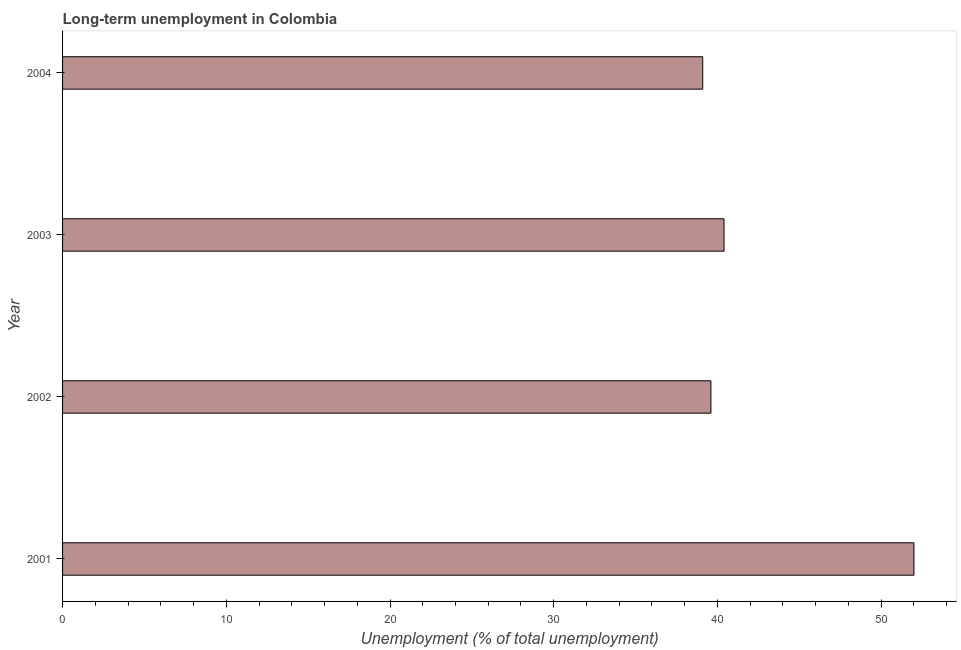What is the title of the graph?
Offer a terse response. Long-term unemployment in Colombia. What is the label or title of the X-axis?
Offer a terse response. Unemployment (% of total unemployment). What is the long-term unemployment in 2001?
Offer a very short reply. 52. Across all years, what is the maximum long-term unemployment?
Your answer should be compact. 52. Across all years, what is the minimum long-term unemployment?
Give a very brief answer. 39.1. In which year was the long-term unemployment maximum?
Provide a short and direct response. 2001. What is the sum of the long-term unemployment?
Your answer should be very brief. 171.1. What is the average long-term unemployment per year?
Offer a terse response. 42.77. Do a majority of the years between 2003 and 2004 (inclusive) have long-term unemployment greater than 6 %?
Your response must be concise. Yes. What is the ratio of the long-term unemployment in 2001 to that in 2004?
Give a very brief answer. 1.33. What is the difference between the highest and the second highest long-term unemployment?
Your answer should be very brief. 11.6. Is the sum of the long-term unemployment in 2001 and 2003 greater than the maximum long-term unemployment across all years?
Ensure brevity in your answer.  Yes. What is the difference between the highest and the lowest long-term unemployment?
Keep it short and to the point. 12.9. In how many years, is the long-term unemployment greater than the average long-term unemployment taken over all years?
Your answer should be compact. 1. Are all the bars in the graph horizontal?
Provide a succinct answer. Yes. How many years are there in the graph?
Ensure brevity in your answer.  4. What is the Unemployment (% of total unemployment) in 2002?
Ensure brevity in your answer.  39.6. What is the Unemployment (% of total unemployment) in 2003?
Your response must be concise. 40.4. What is the Unemployment (% of total unemployment) in 2004?
Your answer should be compact. 39.1. What is the difference between the Unemployment (% of total unemployment) in 2001 and 2002?
Your response must be concise. 12.4. What is the difference between the Unemployment (% of total unemployment) in 2001 and 2003?
Keep it short and to the point. 11.6. What is the difference between the Unemployment (% of total unemployment) in 2001 and 2004?
Make the answer very short. 12.9. What is the difference between the Unemployment (% of total unemployment) in 2002 and 2004?
Offer a very short reply. 0.5. What is the difference between the Unemployment (% of total unemployment) in 2003 and 2004?
Give a very brief answer. 1.3. What is the ratio of the Unemployment (% of total unemployment) in 2001 to that in 2002?
Provide a short and direct response. 1.31. What is the ratio of the Unemployment (% of total unemployment) in 2001 to that in 2003?
Your response must be concise. 1.29. What is the ratio of the Unemployment (% of total unemployment) in 2001 to that in 2004?
Provide a succinct answer. 1.33. What is the ratio of the Unemployment (% of total unemployment) in 2003 to that in 2004?
Your response must be concise. 1.03. 